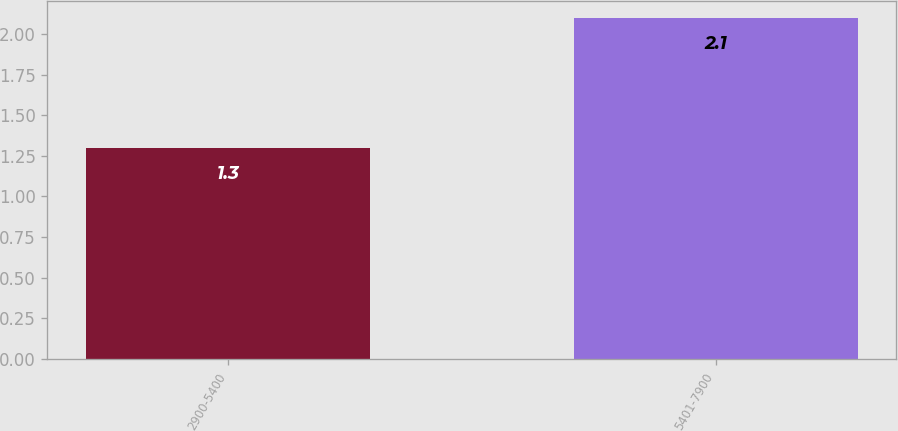Convert chart to OTSL. <chart><loc_0><loc_0><loc_500><loc_500><bar_chart><fcel>2900-5400<fcel>5401-7900<nl><fcel>1.3<fcel>2.1<nl></chart> 